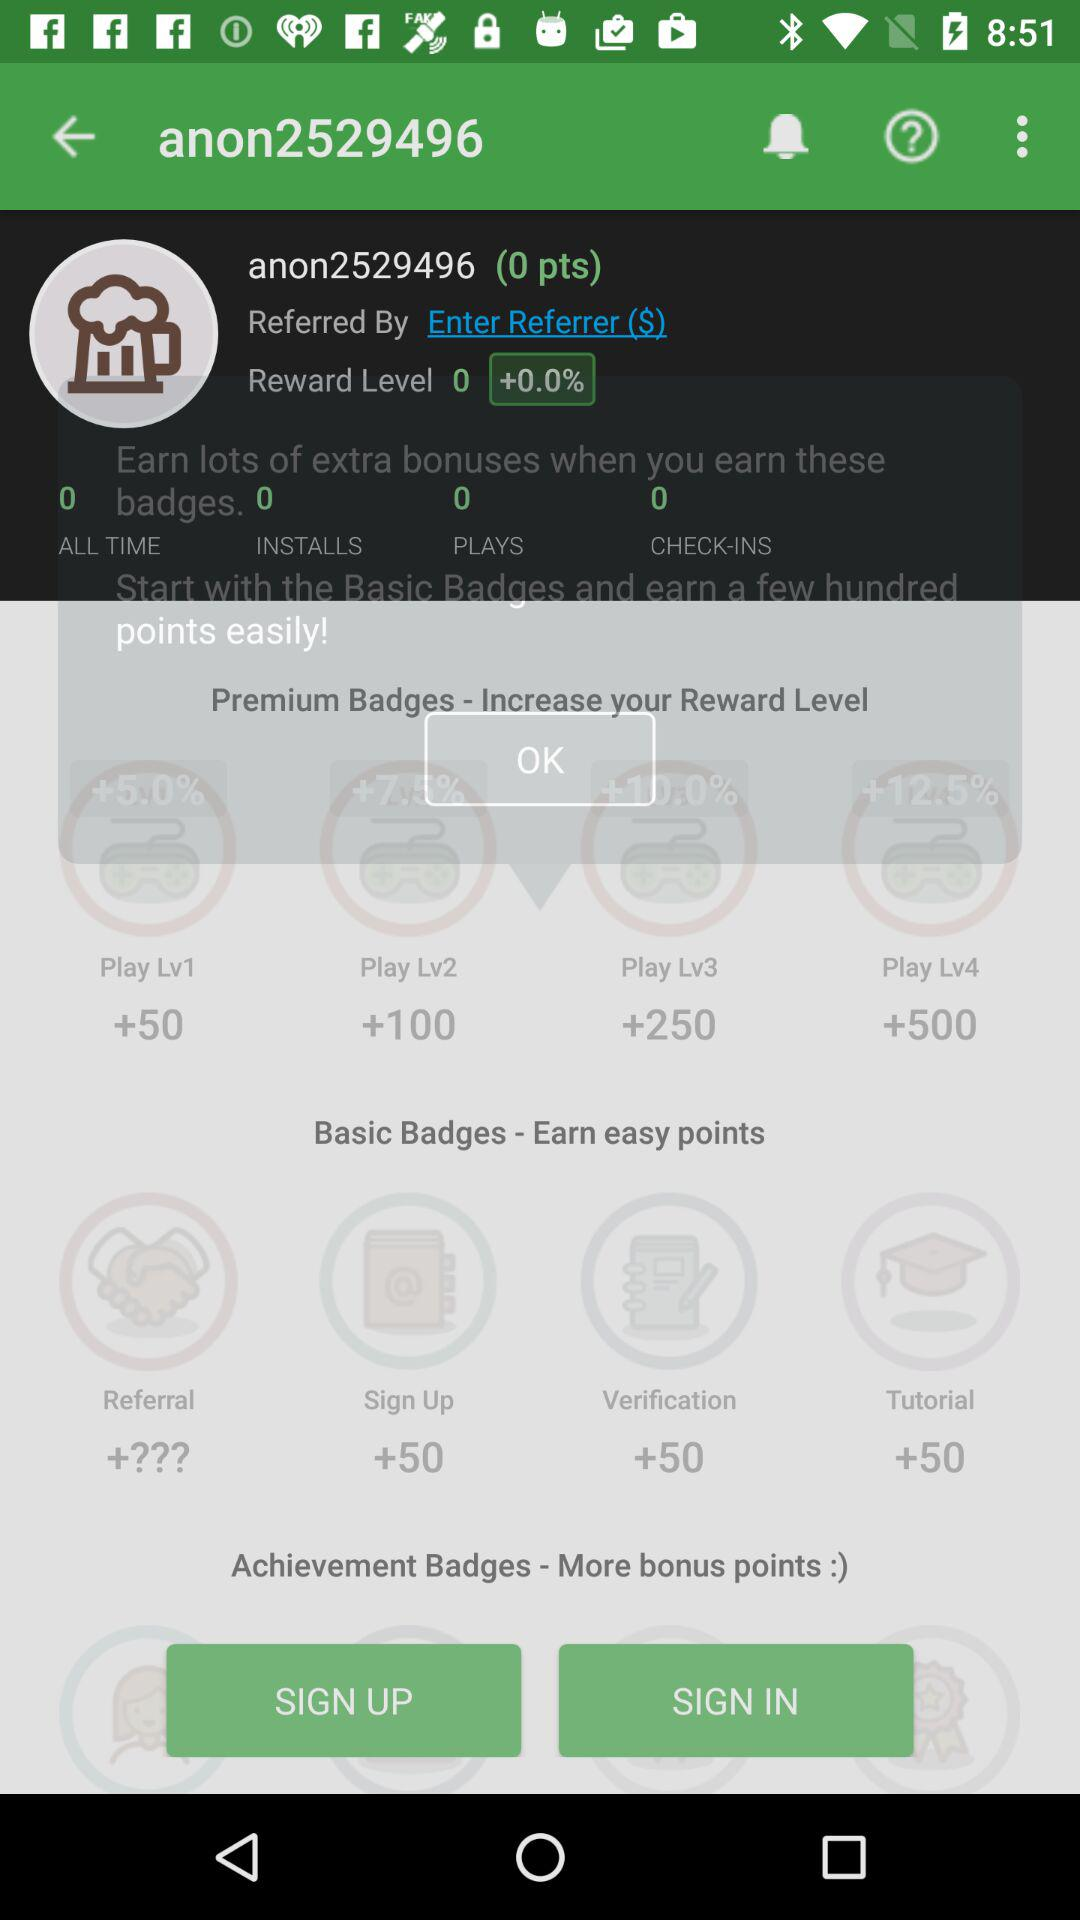What is the username? The username is "anon2529496". 